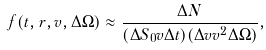<formula> <loc_0><loc_0><loc_500><loc_500>f ( t , { r } , v , \Delta \Omega ) \approx \frac { \Delta N } { ( \Delta S _ { 0 } v \Delta t ) ( \Delta v v ^ { 2 } \Delta \Omega ) } ,</formula> 